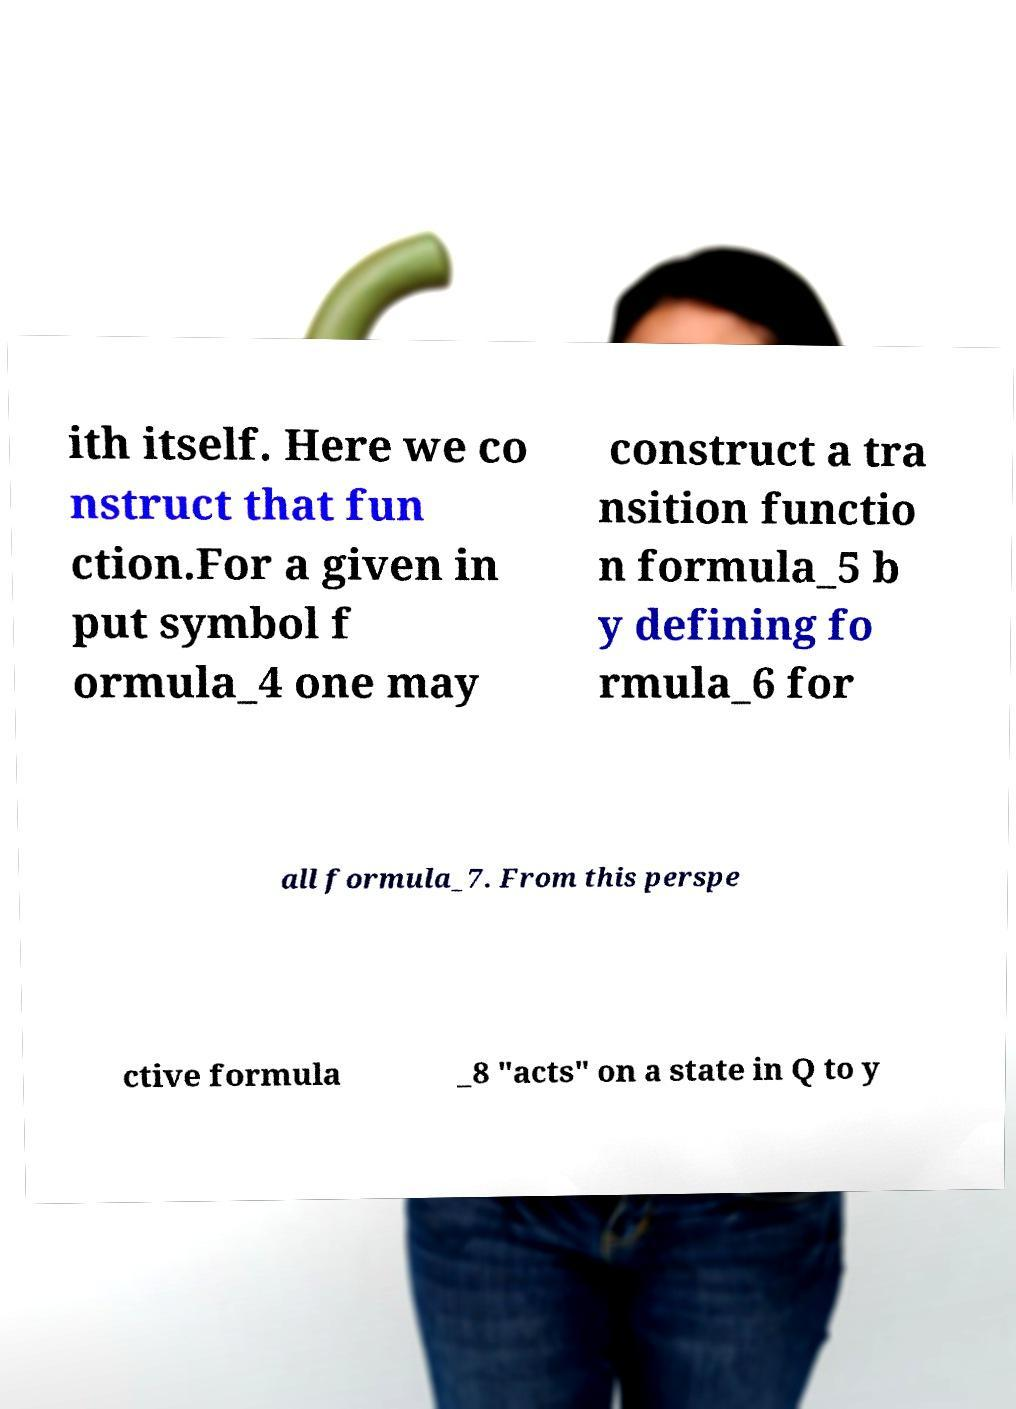I need the written content from this picture converted into text. Can you do that? ith itself. Here we co nstruct that fun ction.For a given in put symbol f ormula_4 one may construct a tra nsition functio n formula_5 b y defining fo rmula_6 for all formula_7. From this perspe ctive formula _8 "acts" on a state in Q to y 